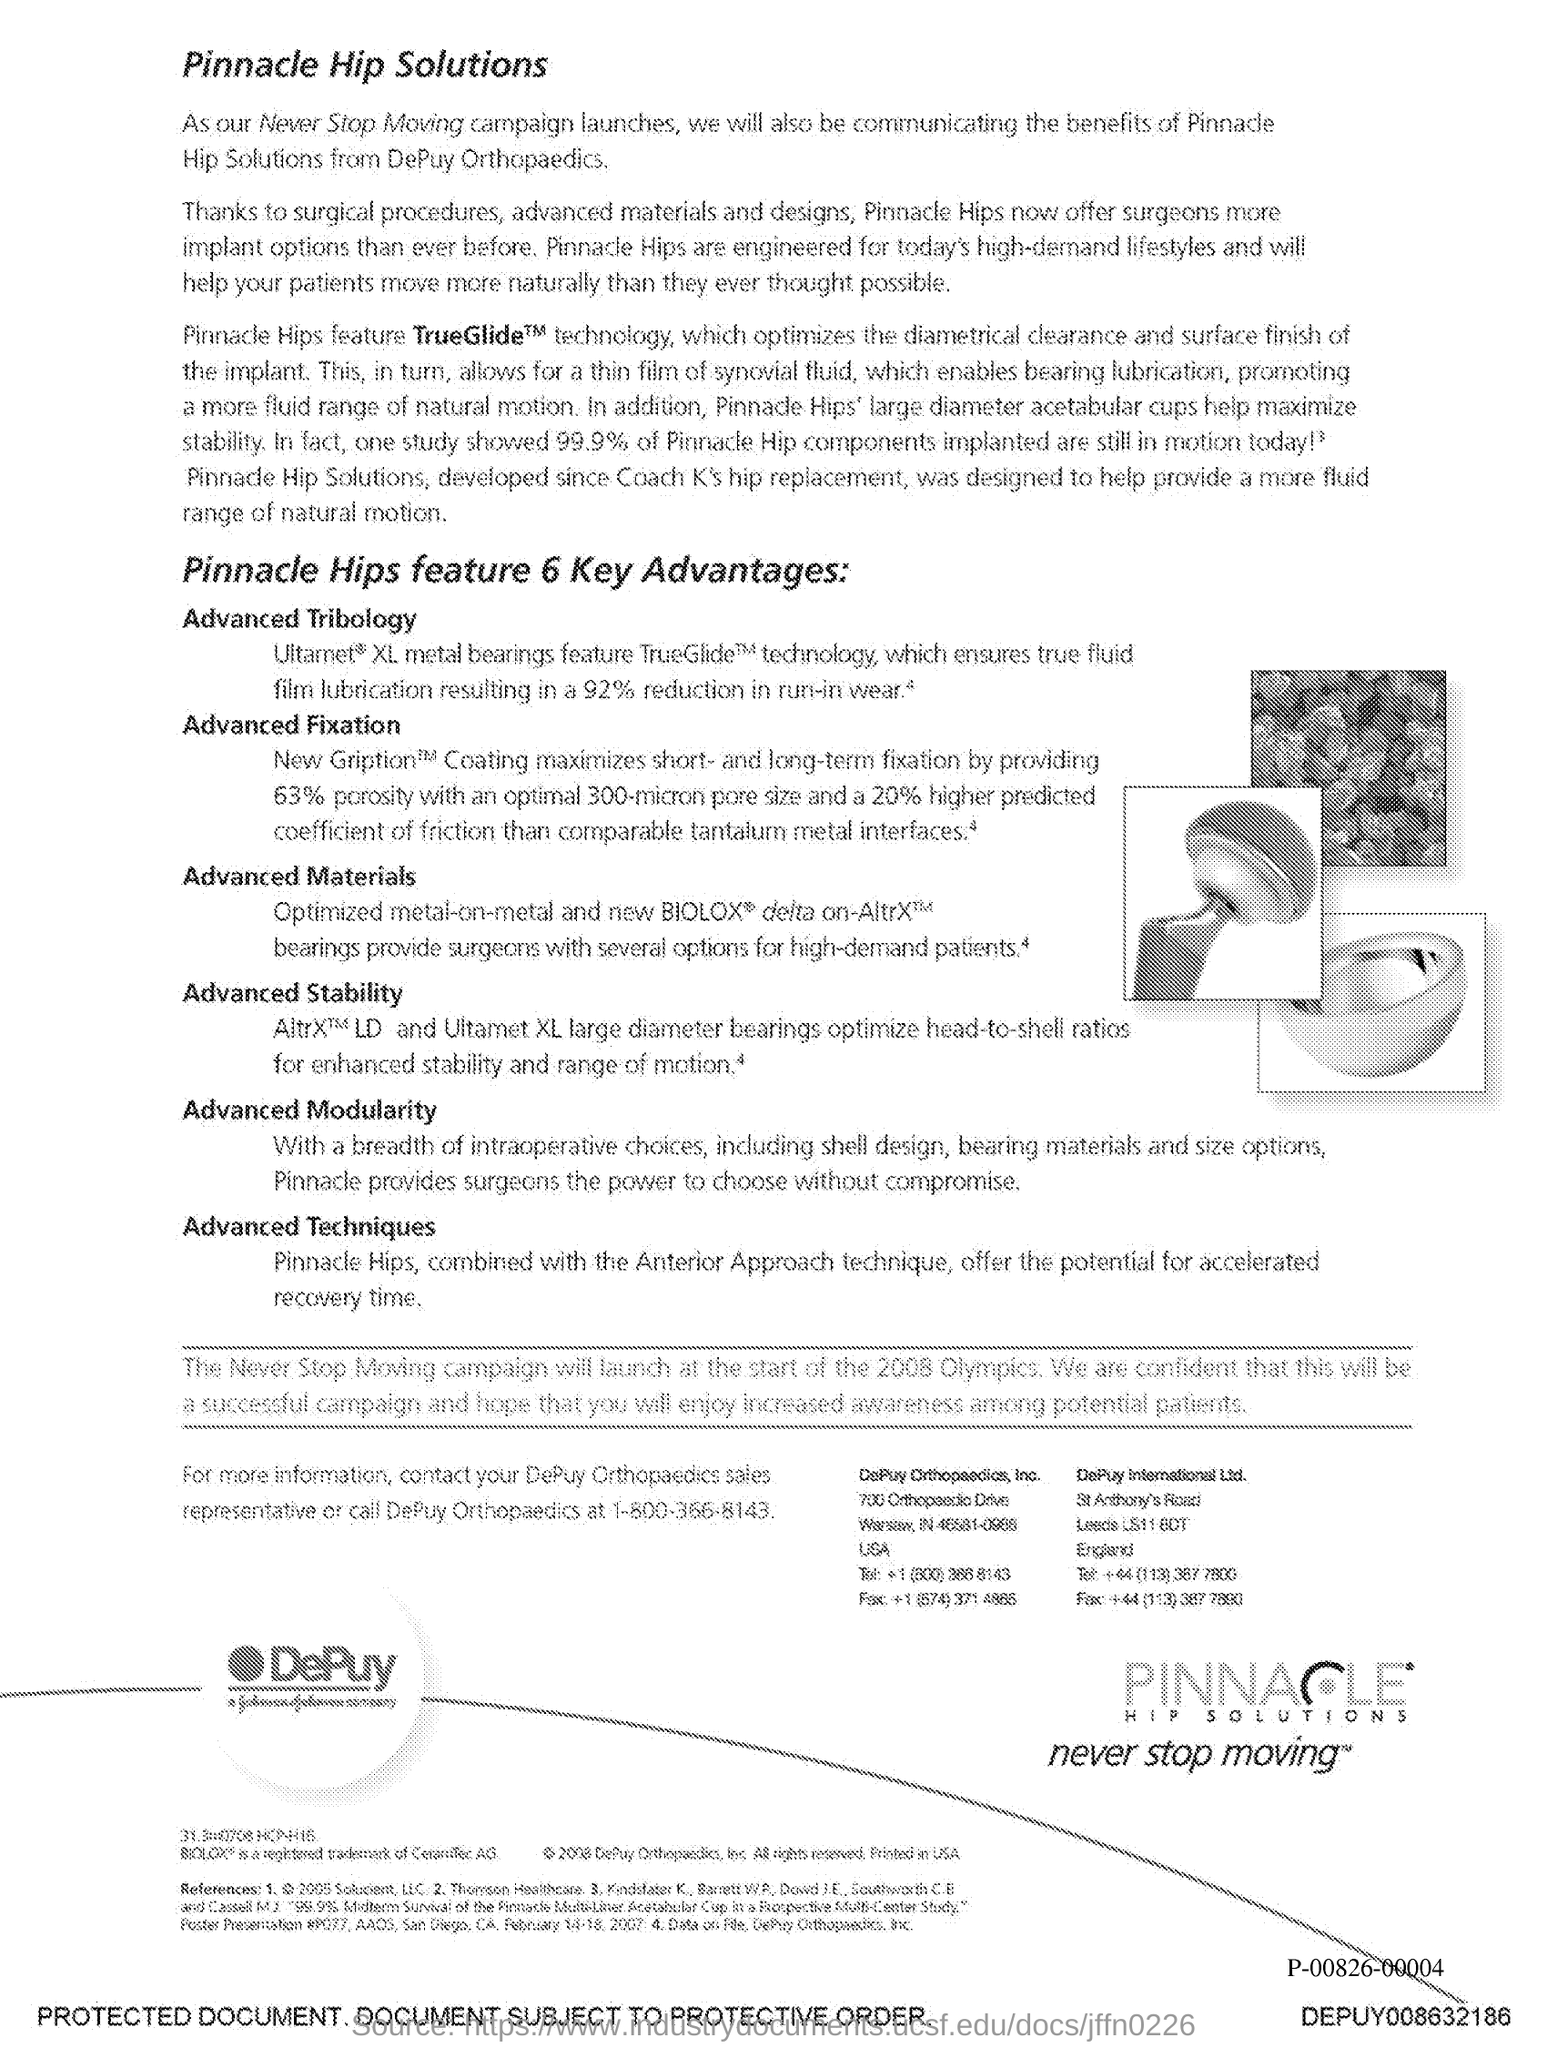What is the first title in the document?
Offer a terse response. Pinnacle Hip Solutions. 